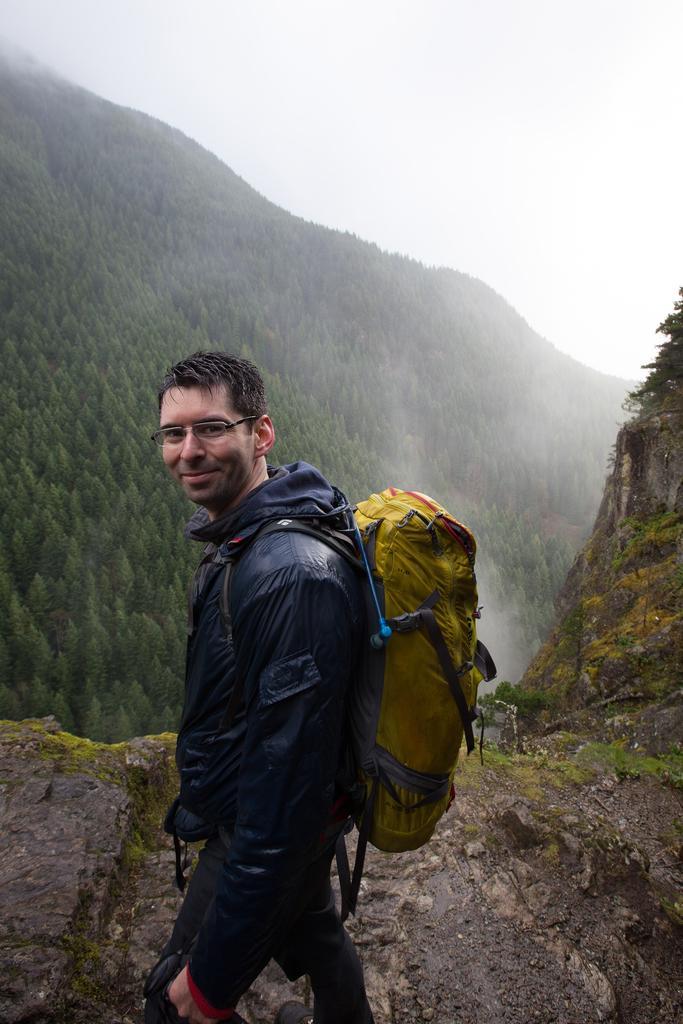Describe this image in one or two sentences. As we can see in the image there is a sky, trees and a man wearing bag. 